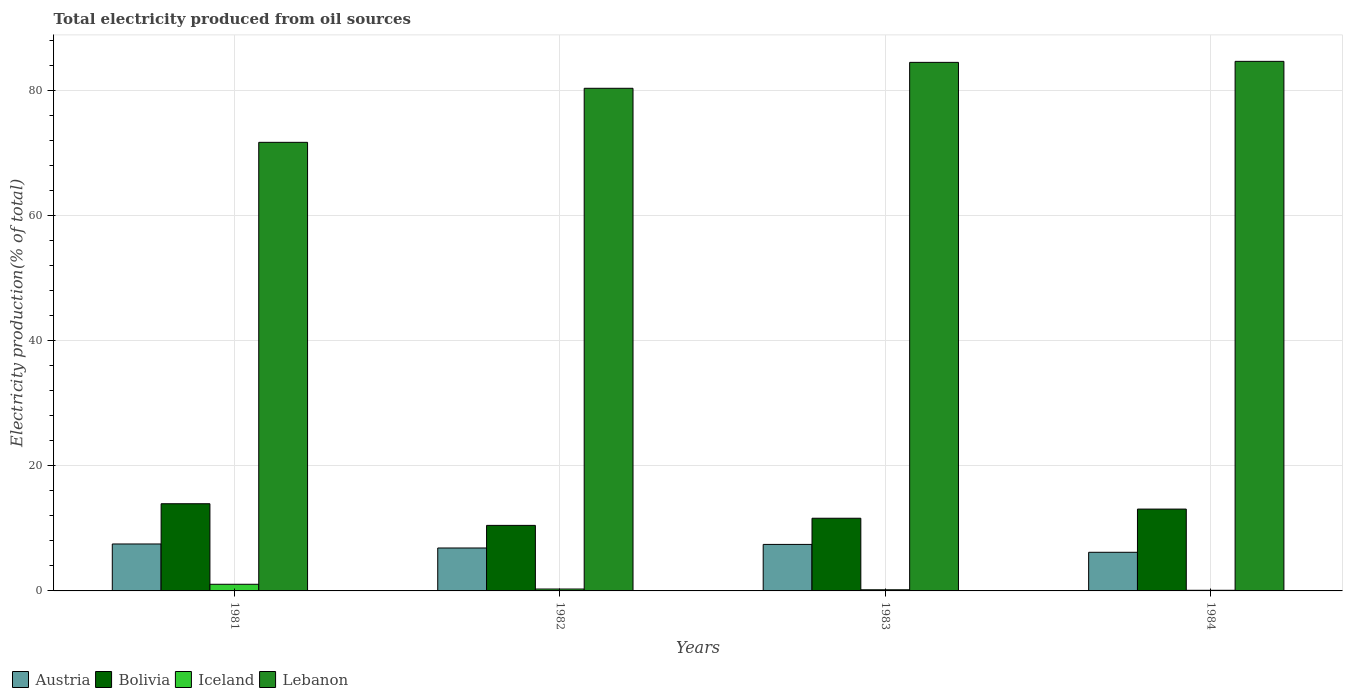How many groups of bars are there?
Your answer should be very brief. 4. Are the number of bars per tick equal to the number of legend labels?
Your response must be concise. Yes. How many bars are there on the 1st tick from the left?
Ensure brevity in your answer.  4. How many bars are there on the 1st tick from the right?
Keep it short and to the point. 4. What is the total electricity produced in Austria in 1982?
Keep it short and to the point. 6.86. Across all years, what is the maximum total electricity produced in Iceland?
Give a very brief answer. 1.06. Across all years, what is the minimum total electricity produced in Austria?
Provide a succinct answer. 6.17. In which year was the total electricity produced in Bolivia maximum?
Ensure brevity in your answer.  1981. In which year was the total electricity produced in Iceland minimum?
Keep it short and to the point. 1984. What is the total total electricity produced in Lebanon in the graph?
Ensure brevity in your answer.  321.02. What is the difference between the total electricity produced in Lebanon in 1982 and that in 1984?
Ensure brevity in your answer.  -4.3. What is the difference between the total electricity produced in Bolivia in 1982 and the total electricity produced in Iceland in 1983?
Your answer should be compact. 10.29. What is the average total electricity produced in Lebanon per year?
Offer a terse response. 80.25. In the year 1982, what is the difference between the total electricity produced in Iceland and total electricity produced in Lebanon?
Your answer should be compact. -80. In how many years, is the total electricity produced in Iceland greater than 60 %?
Your answer should be compact. 0. What is the ratio of the total electricity produced in Iceland in 1982 to that in 1983?
Your response must be concise. 1.66. Is the total electricity produced in Iceland in 1982 less than that in 1983?
Your answer should be very brief. No. What is the difference between the highest and the second highest total electricity produced in Iceland?
Your response must be concise. 0.76. What is the difference between the highest and the lowest total electricity produced in Lebanon?
Offer a terse response. 12.94. In how many years, is the total electricity produced in Lebanon greater than the average total electricity produced in Lebanon taken over all years?
Your response must be concise. 3. What does the 1st bar from the right in 1983 represents?
Your answer should be very brief. Lebanon. Is it the case that in every year, the sum of the total electricity produced in Lebanon and total electricity produced in Iceland is greater than the total electricity produced in Austria?
Ensure brevity in your answer.  Yes. How many years are there in the graph?
Your answer should be very brief. 4. What is the difference between two consecutive major ticks on the Y-axis?
Provide a short and direct response. 20. Are the values on the major ticks of Y-axis written in scientific E-notation?
Your answer should be compact. No. Where does the legend appear in the graph?
Provide a succinct answer. Bottom left. How many legend labels are there?
Your response must be concise. 4. What is the title of the graph?
Give a very brief answer. Total electricity produced from oil sources. What is the label or title of the X-axis?
Provide a succinct answer. Years. What is the Electricity production(% of total) of Austria in 1981?
Give a very brief answer. 7.5. What is the Electricity production(% of total) in Bolivia in 1981?
Provide a short and direct response. 13.93. What is the Electricity production(% of total) of Iceland in 1981?
Your response must be concise. 1.06. What is the Electricity production(% of total) in Lebanon in 1981?
Your response must be concise. 71.67. What is the Electricity production(% of total) of Austria in 1982?
Offer a terse response. 6.86. What is the Electricity production(% of total) in Bolivia in 1982?
Your answer should be compact. 10.47. What is the Electricity production(% of total) in Iceland in 1982?
Your response must be concise. 0.3. What is the Electricity production(% of total) of Lebanon in 1982?
Ensure brevity in your answer.  80.3. What is the Electricity production(% of total) of Austria in 1983?
Make the answer very short. 7.43. What is the Electricity production(% of total) in Bolivia in 1983?
Offer a very short reply. 11.61. What is the Electricity production(% of total) in Iceland in 1983?
Ensure brevity in your answer.  0.18. What is the Electricity production(% of total) in Lebanon in 1983?
Provide a short and direct response. 84.44. What is the Electricity production(% of total) of Austria in 1984?
Your answer should be very brief. 6.17. What is the Electricity production(% of total) in Bolivia in 1984?
Give a very brief answer. 13.07. What is the Electricity production(% of total) of Iceland in 1984?
Provide a short and direct response. 0.1. What is the Electricity production(% of total) in Lebanon in 1984?
Your answer should be very brief. 84.61. Across all years, what is the maximum Electricity production(% of total) in Austria?
Offer a terse response. 7.5. Across all years, what is the maximum Electricity production(% of total) in Bolivia?
Make the answer very short. 13.93. Across all years, what is the maximum Electricity production(% of total) in Iceland?
Make the answer very short. 1.06. Across all years, what is the maximum Electricity production(% of total) of Lebanon?
Keep it short and to the point. 84.61. Across all years, what is the minimum Electricity production(% of total) in Austria?
Keep it short and to the point. 6.17. Across all years, what is the minimum Electricity production(% of total) in Bolivia?
Make the answer very short. 10.47. Across all years, what is the minimum Electricity production(% of total) in Iceland?
Give a very brief answer. 0.1. Across all years, what is the minimum Electricity production(% of total) of Lebanon?
Offer a terse response. 71.67. What is the total Electricity production(% of total) in Austria in the graph?
Keep it short and to the point. 27.96. What is the total Electricity production(% of total) in Bolivia in the graph?
Your response must be concise. 49.09. What is the total Electricity production(% of total) of Iceland in the graph?
Provide a succinct answer. 1.65. What is the total Electricity production(% of total) of Lebanon in the graph?
Keep it short and to the point. 321.02. What is the difference between the Electricity production(% of total) of Austria in 1981 and that in 1982?
Your answer should be compact. 0.64. What is the difference between the Electricity production(% of total) in Bolivia in 1981 and that in 1982?
Offer a very short reply. 3.46. What is the difference between the Electricity production(% of total) of Iceland in 1981 and that in 1982?
Offer a terse response. 0.76. What is the difference between the Electricity production(% of total) of Lebanon in 1981 and that in 1982?
Make the answer very short. -8.64. What is the difference between the Electricity production(% of total) in Austria in 1981 and that in 1983?
Provide a short and direct response. 0.07. What is the difference between the Electricity production(% of total) of Bolivia in 1981 and that in 1983?
Provide a short and direct response. 2.32. What is the difference between the Electricity production(% of total) of Iceland in 1981 and that in 1983?
Keep it short and to the point. 0.88. What is the difference between the Electricity production(% of total) of Lebanon in 1981 and that in 1983?
Offer a very short reply. -12.78. What is the difference between the Electricity production(% of total) of Austria in 1981 and that in 1984?
Offer a terse response. 1.33. What is the difference between the Electricity production(% of total) in Bolivia in 1981 and that in 1984?
Your answer should be very brief. 0.85. What is the difference between the Electricity production(% of total) of Iceland in 1981 and that in 1984?
Provide a succinct answer. 0.96. What is the difference between the Electricity production(% of total) in Lebanon in 1981 and that in 1984?
Provide a short and direct response. -12.94. What is the difference between the Electricity production(% of total) in Austria in 1982 and that in 1983?
Your answer should be very brief. -0.57. What is the difference between the Electricity production(% of total) in Bolivia in 1982 and that in 1983?
Make the answer very short. -1.14. What is the difference between the Electricity production(% of total) in Iceland in 1982 and that in 1983?
Keep it short and to the point. 0.12. What is the difference between the Electricity production(% of total) in Lebanon in 1982 and that in 1983?
Your answer should be compact. -4.14. What is the difference between the Electricity production(% of total) of Austria in 1982 and that in 1984?
Make the answer very short. 0.69. What is the difference between the Electricity production(% of total) of Bolivia in 1982 and that in 1984?
Your response must be concise. -2.6. What is the difference between the Electricity production(% of total) of Iceland in 1982 and that in 1984?
Ensure brevity in your answer.  0.2. What is the difference between the Electricity production(% of total) of Lebanon in 1982 and that in 1984?
Your answer should be very brief. -4.3. What is the difference between the Electricity production(% of total) in Austria in 1983 and that in 1984?
Your answer should be very brief. 1.26. What is the difference between the Electricity production(% of total) of Bolivia in 1983 and that in 1984?
Ensure brevity in your answer.  -1.46. What is the difference between the Electricity production(% of total) in Iceland in 1983 and that in 1984?
Give a very brief answer. 0.08. What is the difference between the Electricity production(% of total) in Lebanon in 1983 and that in 1984?
Offer a very short reply. -0.16. What is the difference between the Electricity production(% of total) of Austria in 1981 and the Electricity production(% of total) of Bolivia in 1982?
Offer a terse response. -2.97. What is the difference between the Electricity production(% of total) of Austria in 1981 and the Electricity production(% of total) of Iceland in 1982?
Ensure brevity in your answer.  7.2. What is the difference between the Electricity production(% of total) in Austria in 1981 and the Electricity production(% of total) in Lebanon in 1982?
Ensure brevity in your answer.  -72.8. What is the difference between the Electricity production(% of total) of Bolivia in 1981 and the Electricity production(% of total) of Iceland in 1982?
Your answer should be compact. 13.63. What is the difference between the Electricity production(% of total) in Bolivia in 1981 and the Electricity production(% of total) in Lebanon in 1982?
Offer a very short reply. -66.37. What is the difference between the Electricity production(% of total) of Iceland in 1981 and the Electricity production(% of total) of Lebanon in 1982?
Offer a terse response. -79.24. What is the difference between the Electricity production(% of total) of Austria in 1981 and the Electricity production(% of total) of Bolivia in 1983?
Your answer should be very brief. -4.11. What is the difference between the Electricity production(% of total) in Austria in 1981 and the Electricity production(% of total) in Iceland in 1983?
Your response must be concise. 7.32. What is the difference between the Electricity production(% of total) of Austria in 1981 and the Electricity production(% of total) of Lebanon in 1983?
Ensure brevity in your answer.  -76.95. What is the difference between the Electricity production(% of total) in Bolivia in 1981 and the Electricity production(% of total) in Iceland in 1983?
Give a very brief answer. 13.75. What is the difference between the Electricity production(% of total) of Bolivia in 1981 and the Electricity production(% of total) of Lebanon in 1983?
Give a very brief answer. -70.52. What is the difference between the Electricity production(% of total) in Iceland in 1981 and the Electricity production(% of total) in Lebanon in 1983?
Provide a short and direct response. -83.38. What is the difference between the Electricity production(% of total) of Austria in 1981 and the Electricity production(% of total) of Bolivia in 1984?
Provide a short and direct response. -5.58. What is the difference between the Electricity production(% of total) of Austria in 1981 and the Electricity production(% of total) of Iceland in 1984?
Offer a very short reply. 7.4. What is the difference between the Electricity production(% of total) of Austria in 1981 and the Electricity production(% of total) of Lebanon in 1984?
Your answer should be compact. -77.11. What is the difference between the Electricity production(% of total) of Bolivia in 1981 and the Electricity production(% of total) of Iceland in 1984?
Your response must be concise. 13.83. What is the difference between the Electricity production(% of total) of Bolivia in 1981 and the Electricity production(% of total) of Lebanon in 1984?
Your response must be concise. -70.68. What is the difference between the Electricity production(% of total) in Iceland in 1981 and the Electricity production(% of total) in Lebanon in 1984?
Offer a terse response. -83.54. What is the difference between the Electricity production(% of total) of Austria in 1982 and the Electricity production(% of total) of Bolivia in 1983?
Offer a very short reply. -4.75. What is the difference between the Electricity production(% of total) of Austria in 1982 and the Electricity production(% of total) of Iceland in 1983?
Offer a terse response. 6.68. What is the difference between the Electricity production(% of total) in Austria in 1982 and the Electricity production(% of total) in Lebanon in 1983?
Offer a very short reply. -77.59. What is the difference between the Electricity production(% of total) of Bolivia in 1982 and the Electricity production(% of total) of Iceland in 1983?
Provide a succinct answer. 10.29. What is the difference between the Electricity production(% of total) in Bolivia in 1982 and the Electricity production(% of total) in Lebanon in 1983?
Provide a succinct answer. -73.97. What is the difference between the Electricity production(% of total) in Iceland in 1982 and the Electricity production(% of total) in Lebanon in 1983?
Your answer should be compact. -84.14. What is the difference between the Electricity production(% of total) of Austria in 1982 and the Electricity production(% of total) of Bolivia in 1984?
Offer a very short reply. -6.22. What is the difference between the Electricity production(% of total) in Austria in 1982 and the Electricity production(% of total) in Iceland in 1984?
Provide a short and direct response. 6.76. What is the difference between the Electricity production(% of total) of Austria in 1982 and the Electricity production(% of total) of Lebanon in 1984?
Your answer should be compact. -77.75. What is the difference between the Electricity production(% of total) of Bolivia in 1982 and the Electricity production(% of total) of Iceland in 1984?
Your answer should be compact. 10.37. What is the difference between the Electricity production(% of total) of Bolivia in 1982 and the Electricity production(% of total) of Lebanon in 1984?
Your answer should be very brief. -74.13. What is the difference between the Electricity production(% of total) of Iceland in 1982 and the Electricity production(% of total) of Lebanon in 1984?
Your answer should be compact. -84.3. What is the difference between the Electricity production(% of total) in Austria in 1983 and the Electricity production(% of total) in Bolivia in 1984?
Provide a short and direct response. -5.64. What is the difference between the Electricity production(% of total) of Austria in 1983 and the Electricity production(% of total) of Iceland in 1984?
Your answer should be very brief. 7.33. What is the difference between the Electricity production(% of total) in Austria in 1983 and the Electricity production(% of total) in Lebanon in 1984?
Keep it short and to the point. -77.17. What is the difference between the Electricity production(% of total) of Bolivia in 1983 and the Electricity production(% of total) of Iceland in 1984?
Provide a succinct answer. 11.51. What is the difference between the Electricity production(% of total) of Bolivia in 1983 and the Electricity production(% of total) of Lebanon in 1984?
Offer a very short reply. -72.99. What is the difference between the Electricity production(% of total) in Iceland in 1983 and the Electricity production(% of total) in Lebanon in 1984?
Keep it short and to the point. -84.42. What is the average Electricity production(% of total) in Austria per year?
Provide a short and direct response. 6.99. What is the average Electricity production(% of total) of Bolivia per year?
Provide a short and direct response. 12.27. What is the average Electricity production(% of total) of Iceland per year?
Offer a very short reply. 0.41. What is the average Electricity production(% of total) in Lebanon per year?
Provide a succinct answer. 80.25. In the year 1981, what is the difference between the Electricity production(% of total) in Austria and Electricity production(% of total) in Bolivia?
Make the answer very short. -6.43. In the year 1981, what is the difference between the Electricity production(% of total) of Austria and Electricity production(% of total) of Iceland?
Your response must be concise. 6.44. In the year 1981, what is the difference between the Electricity production(% of total) of Austria and Electricity production(% of total) of Lebanon?
Keep it short and to the point. -64.17. In the year 1981, what is the difference between the Electricity production(% of total) of Bolivia and Electricity production(% of total) of Iceland?
Your answer should be compact. 12.87. In the year 1981, what is the difference between the Electricity production(% of total) in Bolivia and Electricity production(% of total) in Lebanon?
Provide a succinct answer. -57.74. In the year 1981, what is the difference between the Electricity production(% of total) of Iceland and Electricity production(% of total) of Lebanon?
Keep it short and to the point. -70.6. In the year 1982, what is the difference between the Electricity production(% of total) of Austria and Electricity production(% of total) of Bolivia?
Provide a succinct answer. -3.61. In the year 1982, what is the difference between the Electricity production(% of total) of Austria and Electricity production(% of total) of Iceland?
Make the answer very short. 6.56. In the year 1982, what is the difference between the Electricity production(% of total) of Austria and Electricity production(% of total) of Lebanon?
Keep it short and to the point. -73.44. In the year 1982, what is the difference between the Electricity production(% of total) in Bolivia and Electricity production(% of total) in Iceland?
Keep it short and to the point. 10.17. In the year 1982, what is the difference between the Electricity production(% of total) in Bolivia and Electricity production(% of total) in Lebanon?
Make the answer very short. -69.83. In the year 1982, what is the difference between the Electricity production(% of total) of Iceland and Electricity production(% of total) of Lebanon?
Offer a very short reply. -80. In the year 1983, what is the difference between the Electricity production(% of total) of Austria and Electricity production(% of total) of Bolivia?
Provide a succinct answer. -4.18. In the year 1983, what is the difference between the Electricity production(% of total) of Austria and Electricity production(% of total) of Iceland?
Provide a succinct answer. 7.25. In the year 1983, what is the difference between the Electricity production(% of total) in Austria and Electricity production(% of total) in Lebanon?
Ensure brevity in your answer.  -77.01. In the year 1983, what is the difference between the Electricity production(% of total) in Bolivia and Electricity production(% of total) in Iceland?
Make the answer very short. 11.43. In the year 1983, what is the difference between the Electricity production(% of total) of Bolivia and Electricity production(% of total) of Lebanon?
Keep it short and to the point. -72.83. In the year 1983, what is the difference between the Electricity production(% of total) in Iceland and Electricity production(% of total) in Lebanon?
Offer a very short reply. -84.26. In the year 1984, what is the difference between the Electricity production(% of total) in Austria and Electricity production(% of total) in Bolivia?
Offer a very short reply. -6.9. In the year 1984, what is the difference between the Electricity production(% of total) in Austria and Electricity production(% of total) in Iceland?
Make the answer very short. 6.07. In the year 1984, what is the difference between the Electricity production(% of total) in Austria and Electricity production(% of total) in Lebanon?
Your response must be concise. -78.43. In the year 1984, what is the difference between the Electricity production(% of total) in Bolivia and Electricity production(% of total) in Iceland?
Provide a short and direct response. 12.97. In the year 1984, what is the difference between the Electricity production(% of total) of Bolivia and Electricity production(% of total) of Lebanon?
Offer a terse response. -71.53. In the year 1984, what is the difference between the Electricity production(% of total) of Iceland and Electricity production(% of total) of Lebanon?
Offer a terse response. -84.5. What is the ratio of the Electricity production(% of total) in Austria in 1981 to that in 1982?
Offer a very short reply. 1.09. What is the ratio of the Electricity production(% of total) of Bolivia in 1981 to that in 1982?
Your answer should be very brief. 1.33. What is the ratio of the Electricity production(% of total) of Iceland in 1981 to that in 1982?
Ensure brevity in your answer.  3.51. What is the ratio of the Electricity production(% of total) in Lebanon in 1981 to that in 1982?
Your answer should be compact. 0.89. What is the ratio of the Electricity production(% of total) of Austria in 1981 to that in 1983?
Provide a succinct answer. 1.01. What is the ratio of the Electricity production(% of total) of Bolivia in 1981 to that in 1983?
Provide a succinct answer. 1.2. What is the ratio of the Electricity production(% of total) of Iceland in 1981 to that in 1983?
Offer a terse response. 5.81. What is the ratio of the Electricity production(% of total) of Lebanon in 1981 to that in 1983?
Provide a succinct answer. 0.85. What is the ratio of the Electricity production(% of total) of Austria in 1981 to that in 1984?
Give a very brief answer. 1.22. What is the ratio of the Electricity production(% of total) of Bolivia in 1981 to that in 1984?
Provide a short and direct response. 1.07. What is the ratio of the Electricity production(% of total) of Iceland in 1981 to that in 1984?
Your answer should be compact. 10.56. What is the ratio of the Electricity production(% of total) in Lebanon in 1981 to that in 1984?
Make the answer very short. 0.85. What is the ratio of the Electricity production(% of total) of Austria in 1982 to that in 1983?
Offer a terse response. 0.92. What is the ratio of the Electricity production(% of total) of Bolivia in 1982 to that in 1983?
Make the answer very short. 0.9. What is the ratio of the Electricity production(% of total) in Iceland in 1982 to that in 1983?
Offer a terse response. 1.66. What is the ratio of the Electricity production(% of total) in Lebanon in 1982 to that in 1983?
Your answer should be compact. 0.95. What is the ratio of the Electricity production(% of total) in Austria in 1982 to that in 1984?
Offer a terse response. 1.11. What is the ratio of the Electricity production(% of total) of Bolivia in 1982 to that in 1984?
Your answer should be compact. 0.8. What is the ratio of the Electricity production(% of total) in Iceland in 1982 to that in 1984?
Provide a succinct answer. 3.01. What is the ratio of the Electricity production(% of total) in Lebanon in 1982 to that in 1984?
Provide a short and direct response. 0.95. What is the ratio of the Electricity production(% of total) in Austria in 1983 to that in 1984?
Keep it short and to the point. 1.2. What is the ratio of the Electricity production(% of total) in Bolivia in 1983 to that in 1984?
Offer a terse response. 0.89. What is the ratio of the Electricity production(% of total) in Iceland in 1983 to that in 1984?
Your response must be concise. 1.82. What is the difference between the highest and the second highest Electricity production(% of total) in Austria?
Provide a short and direct response. 0.07. What is the difference between the highest and the second highest Electricity production(% of total) of Bolivia?
Offer a very short reply. 0.85. What is the difference between the highest and the second highest Electricity production(% of total) of Iceland?
Make the answer very short. 0.76. What is the difference between the highest and the second highest Electricity production(% of total) in Lebanon?
Your answer should be compact. 0.16. What is the difference between the highest and the lowest Electricity production(% of total) of Austria?
Keep it short and to the point. 1.33. What is the difference between the highest and the lowest Electricity production(% of total) in Bolivia?
Keep it short and to the point. 3.46. What is the difference between the highest and the lowest Electricity production(% of total) of Iceland?
Your response must be concise. 0.96. What is the difference between the highest and the lowest Electricity production(% of total) of Lebanon?
Provide a short and direct response. 12.94. 